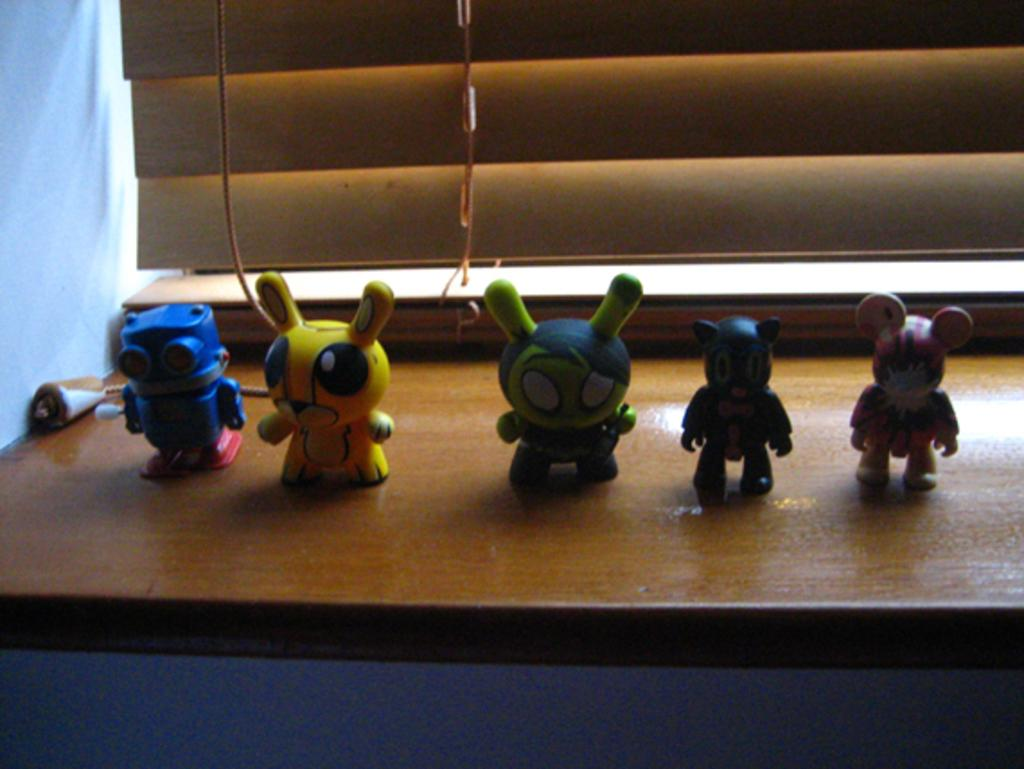What is the main subject of the image? The main subject of the image is toys. Where are the toys located? The toys are on a desk. What can be seen at the top side of the image? There is a window at the top side of the image. What type of insect can be seen crawling on the toys in the image? There is no insect present in the image; it only features toys on a desk. What type of legal advice is being given in the image? There is no lawyer or legal advice present in the image; it only features toys on a desk. 